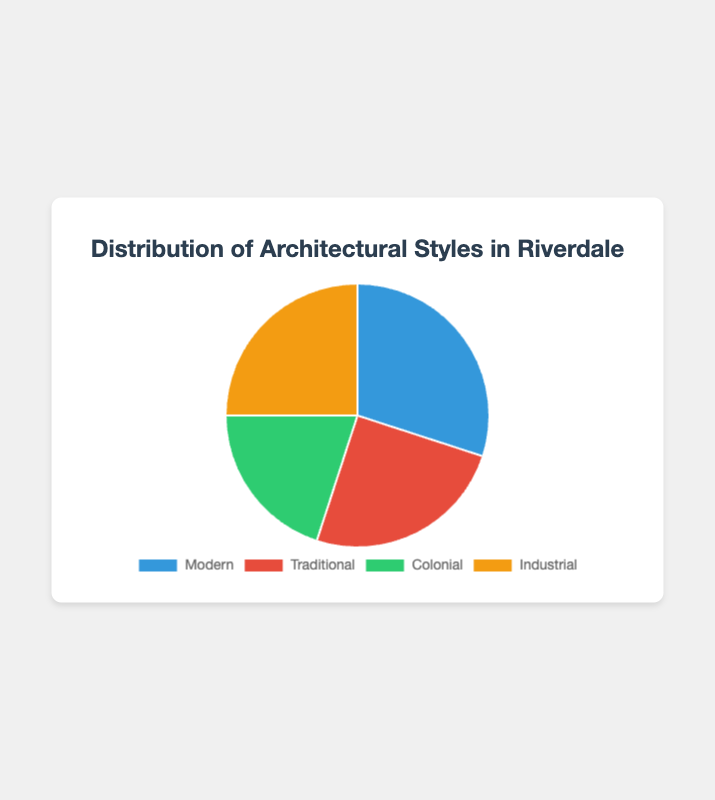What's the predominant architectural style in Riverdale? The predominant style is the one with the highest percentage. Represented by the largest slice in the pie chart, Modern (30%) is the most prevalent.
Answer: Modern Which styles share the same percentage of distribution? According to the chart, Traditional and Industrial both cover 25%, indicated by slices of identical size.
Answer: Traditional and Industrial How much more prevalent is the Modern style compared to the Colonial style? Subtract the percentage of Colonial (20%) from Modern (30%) to find the difference. 30% - 20% = 10%.
Answer: 10% What are the combined percentages of Traditional and Industrial styles? Add the percentages of both styles: 25% + 25% = 50%.
Answer: 50% Of Modern, Traditional, and Colonial styles, which one is the least represented? Compare the percentages: Modern (30%), Traditional (25%), and Colonial (20%). The smallest percentage is Colonial.
Answer: Colonial What's the least prevalent style in Riverdale when compared to its distribution percentage? The least prevalent style has the smallest percent, which, according to the chart, is Colonial at 20%.
Answer: Colonial If you were to combine the two least represented styles, what percentage would they represent? The two least represented styles are Colonial (20%) and Traditional (25%). Adding their percentages results in 20% + 25% = 45%.
Answer: 45% What color is associated with the least represented architectural style? The slice representing Colonial (20%) is green, indicating its association with the least represented style.
Answer: Green How does the percentage of Traditional style homes compare to that of Colonial styles? Traditional has 25% and Colonial 20%, meaning the Traditional style has 5% more. 25% - 20% = 5%.
Answer: 5% What color represents the Modern style in the pie chart? The slice for Modern, which makes up 30%, is displayed in blue according to the chart.
Answer: Blue 